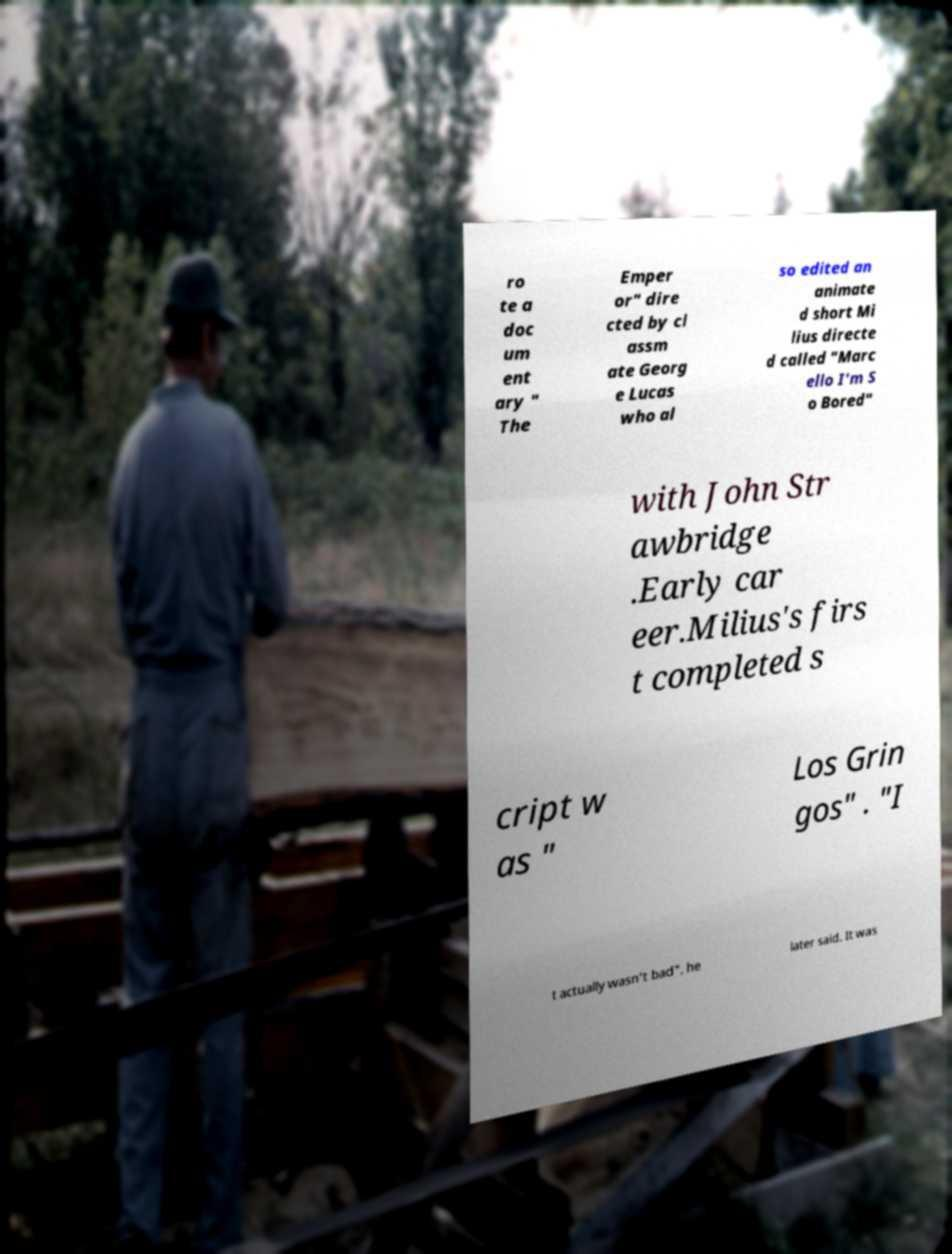Could you extract and type out the text from this image? ro te a doc um ent ary " The Emper or" dire cted by cl assm ate Georg e Lucas who al so edited an animate d short Mi lius directe d called "Marc ello I'm S o Bored" with John Str awbridge .Early car eer.Milius's firs t completed s cript w as " Los Grin gos" . "I t actually wasn't bad", he later said. It was 